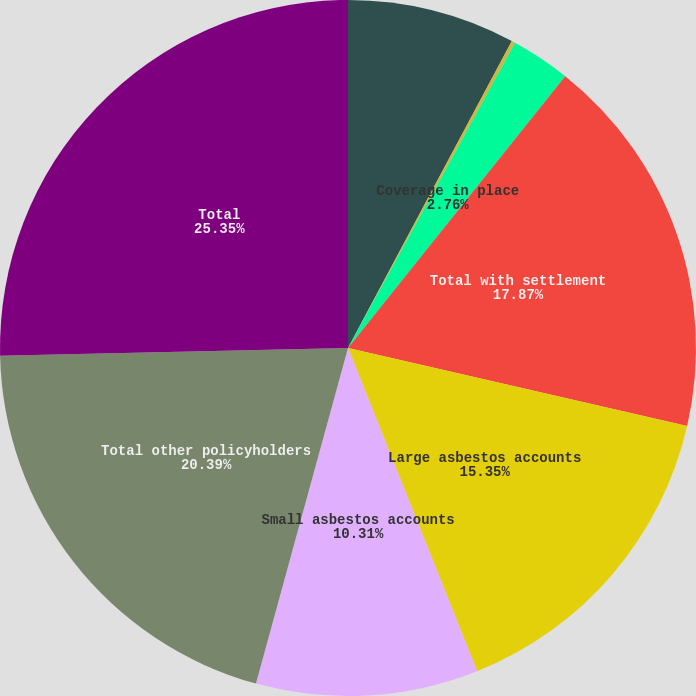Convert chart to OTSL. <chart><loc_0><loc_0><loc_500><loc_500><pie_chart><fcel>Structured settlements<fcel>Wellington<fcel>Coverage in place<fcel>Total with settlement<fcel>Large asbestos accounts<fcel>Small asbestos accounts<fcel>Total other policyholders<fcel>Total<nl><fcel>7.8%<fcel>0.17%<fcel>2.76%<fcel>17.87%<fcel>15.35%<fcel>10.31%<fcel>20.39%<fcel>25.35%<nl></chart> 